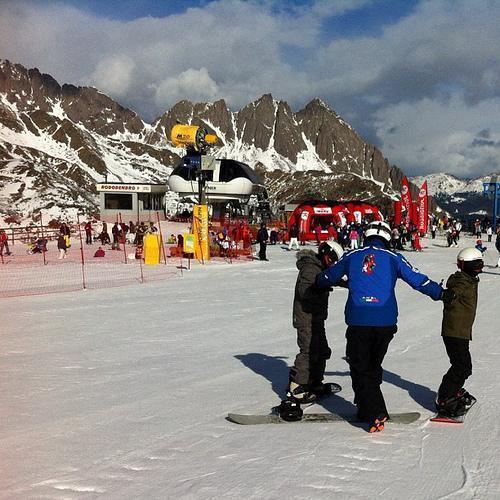How many distinguishable faces?
Give a very brief answer. 0. 